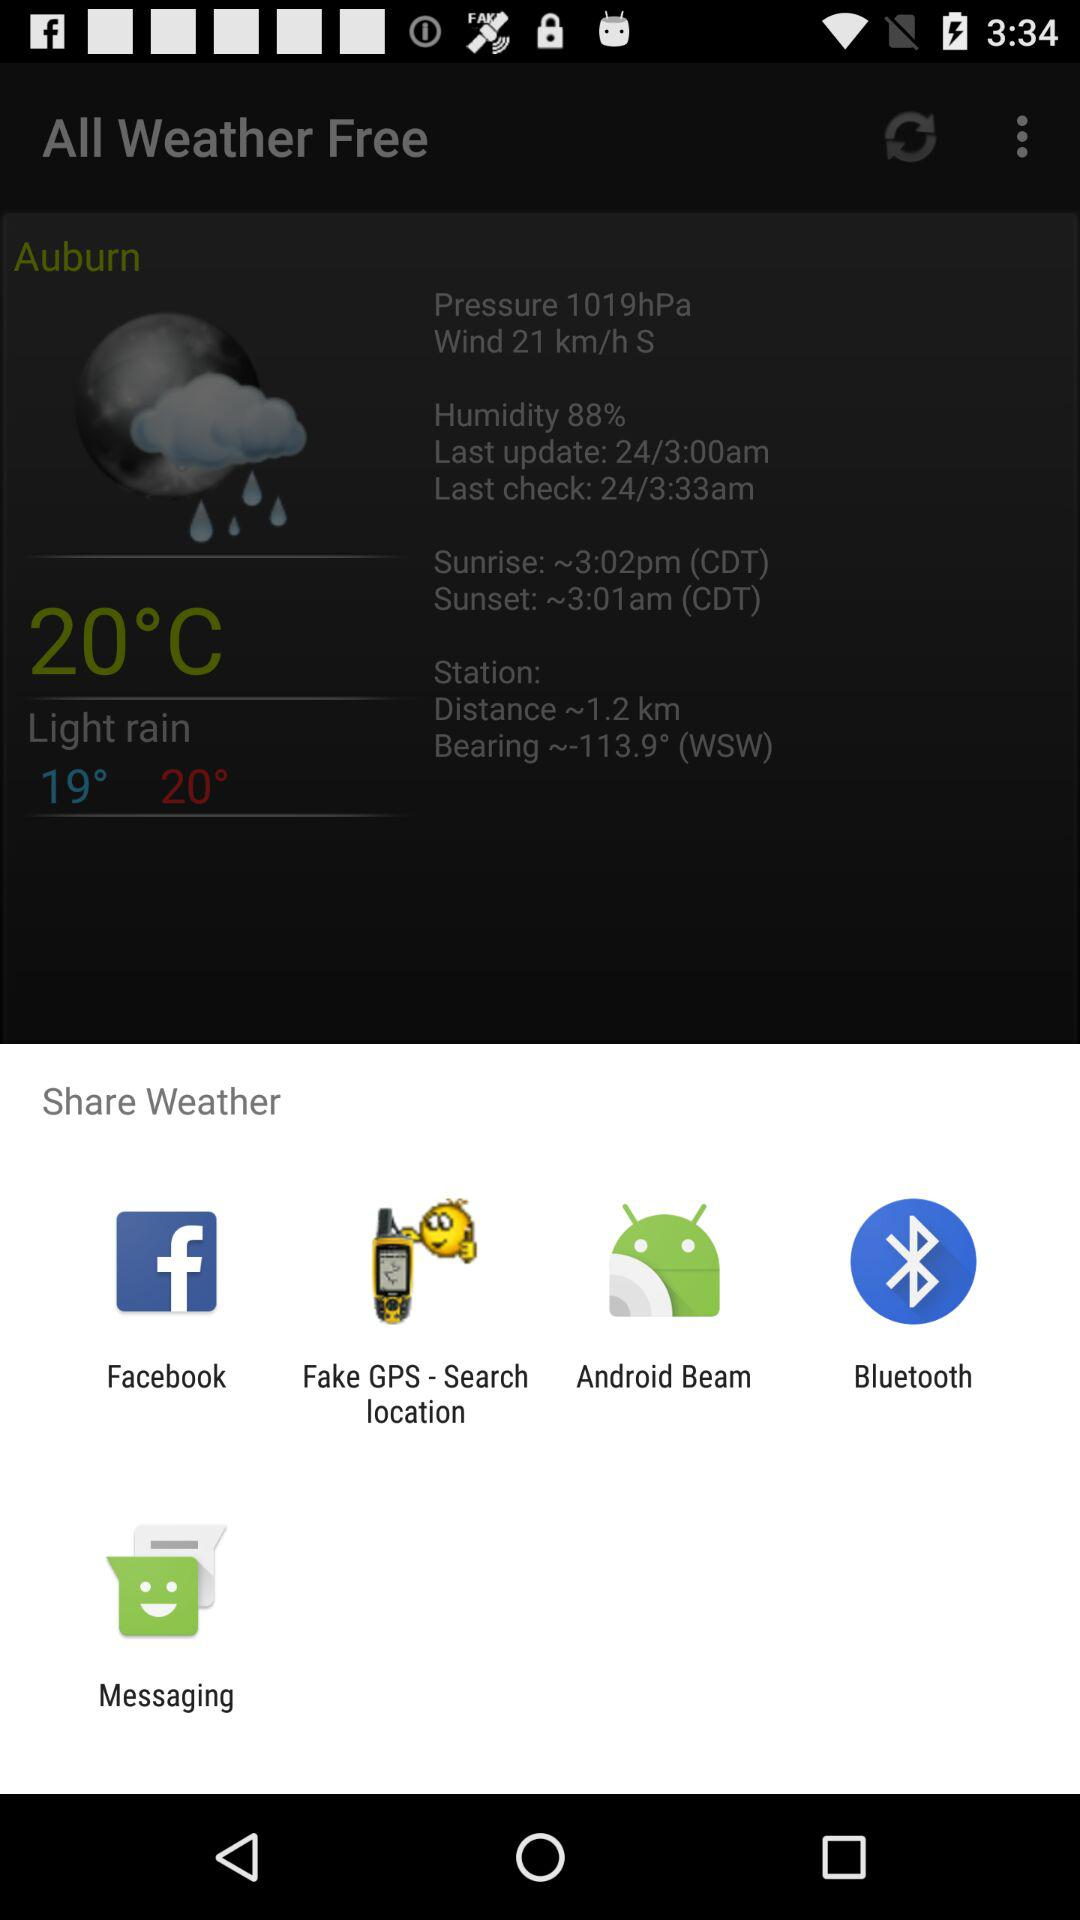Through what applications can we share? The applications are "Facebook", "Fake GPS-Search location", "Android Beam", "Bluetooth", and "Messaging". 